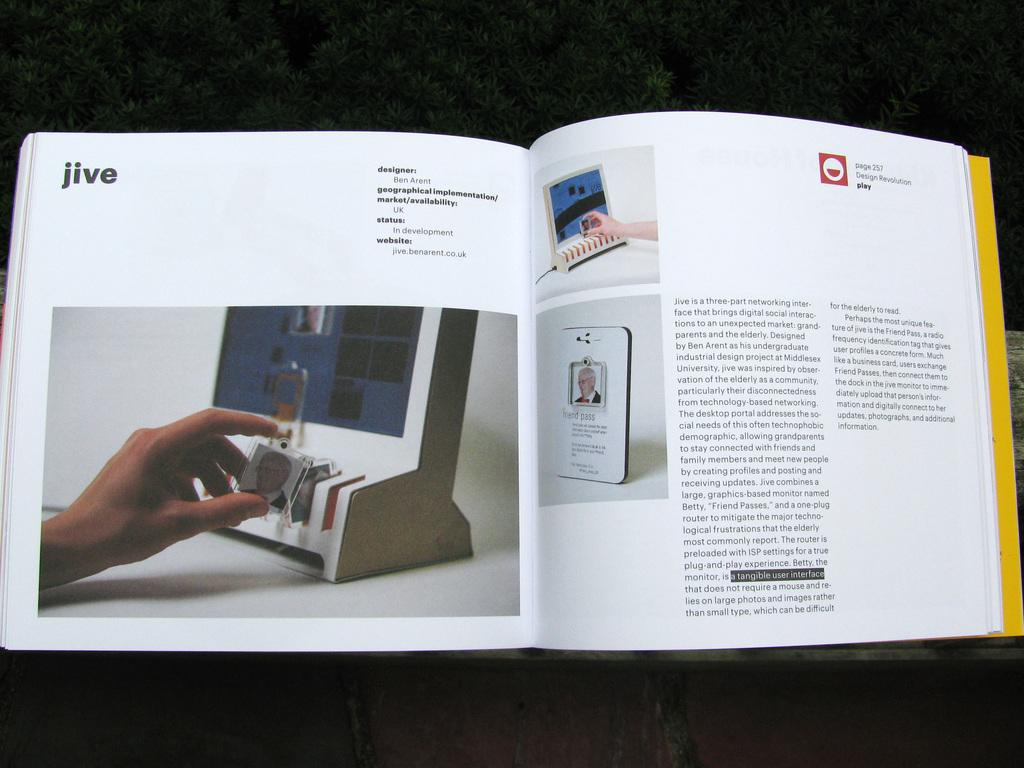Provide a one-sentence caption for the provided image. A book is open to a page about jive. 